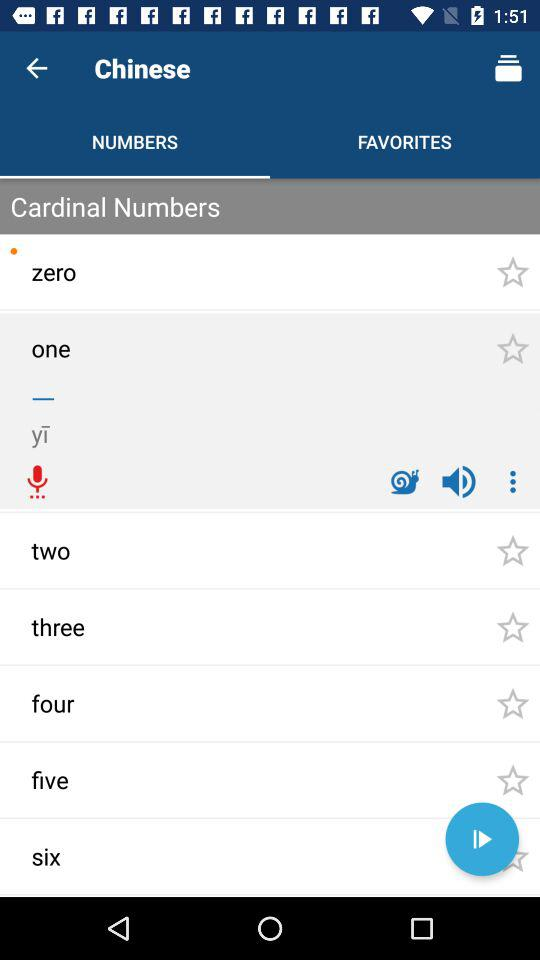How many more numbers are there after the zero than before the zero?
Answer the question using a single word or phrase. 6 